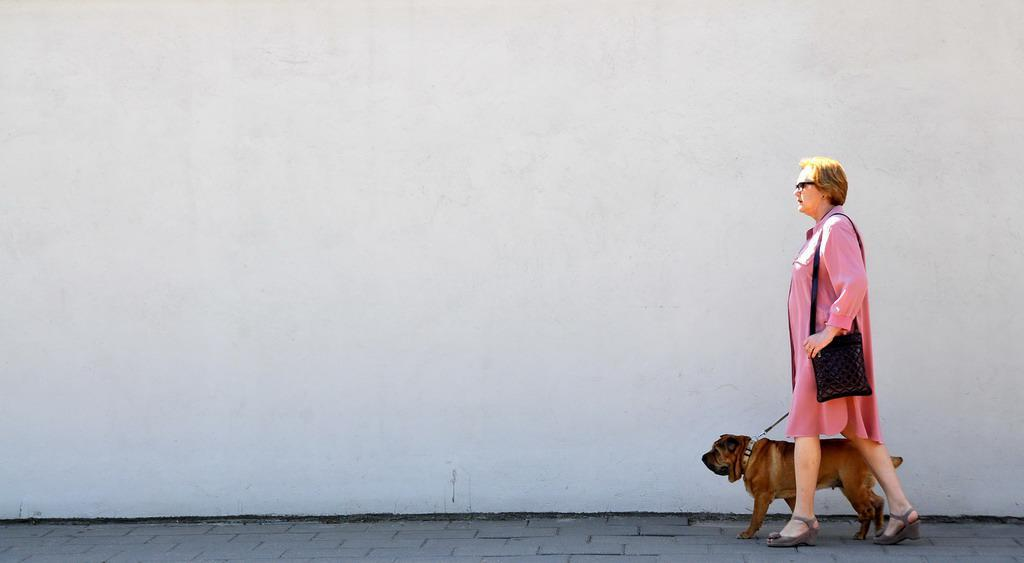Who is present in the image? There is a woman in the image. What other living being is present in the image? There is a dog in the image. What are the woman and the dog doing in the image? The woman and the dog are walking on the road. What is the woman carrying in the image? The woman is wearing a black color bag. What can be seen in the background of the image? There is a wall in the background of the image. What songs can be heard playing in the background of the image? There is no audio or music present in the image, so it is not possible to determine what songs might be heard. 